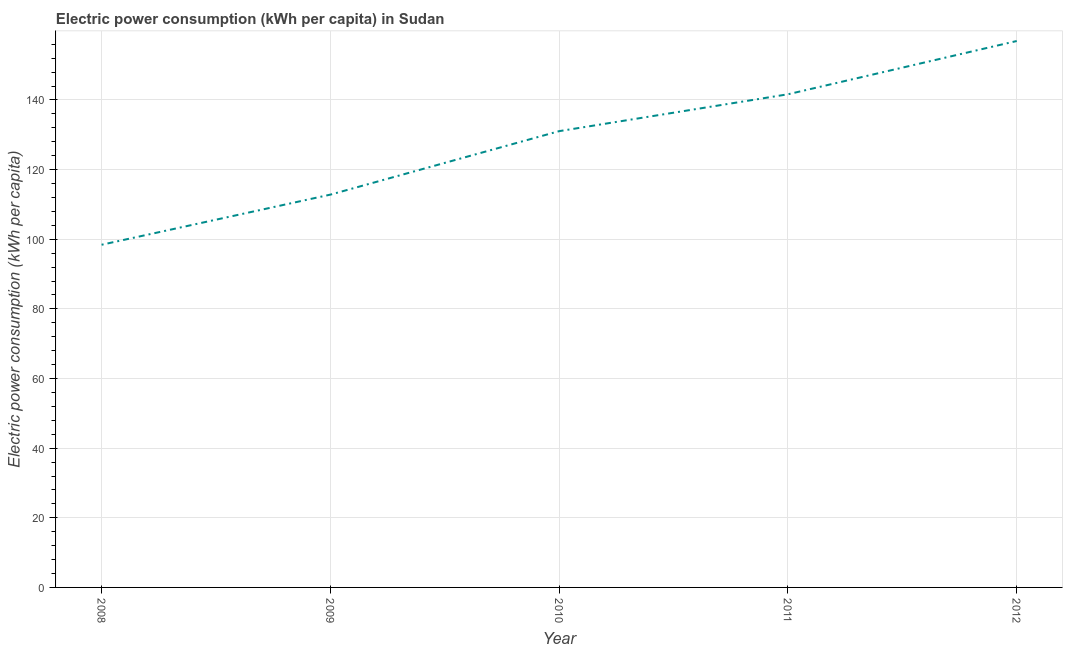What is the electric power consumption in 2009?
Make the answer very short. 112.82. Across all years, what is the maximum electric power consumption?
Provide a succinct answer. 156.94. Across all years, what is the minimum electric power consumption?
Keep it short and to the point. 98.42. In which year was the electric power consumption maximum?
Your answer should be compact. 2012. In which year was the electric power consumption minimum?
Give a very brief answer. 2008. What is the sum of the electric power consumption?
Give a very brief answer. 640.89. What is the difference between the electric power consumption in 2009 and 2012?
Offer a very short reply. -44.12. What is the average electric power consumption per year?
Ensure brevity in your answer.  128.18. What is the median electric power consumption?
Provide a short and direct response. 131.06. Do a majority of the years between 2009 and 2012 (inclusive) have electric power consumption greater than 92 kWh per capita?
Offer a terse response. Yes. What is the ratio of the electric power consumption in 2008 to that in 2012?
Offer a very short reply. 0.63. Is the electric power consumption in 2010 less than that in 2012?
Ensure brevity in your answer.  Yes. What is the difference between the highest and the second highest electric power consumption?
Offer a very short reply. 15.3. Is the sum of the electric power consumption in 2011 and 2012 greater than the maximum electric power consumption across all years?
Provide a succinct answer. Yes. What is the difference between the highest and the lowest electric power consumption?
Your response must be concise. 58.52. How many lines are there?
Ensure brevity in your answer.  1. How many years are there in the graph?
Make the answer very short. 5. Are the values on the major ticks of Y-axis written in scientific E-notation?
Provide a succinct answer. No. Does the graph contain any zero values?
Your answer should be very brief. No. Does the graph contain grids?
Make the answer very short. Yes. What is the title of the graph?
Ensure brevity in your answer.  Electric power consumption (kWh per capita) in Sudan. What is the label or title of the Y-axis?
Make the answer very short. Electric power consumption (kWh per capita). What is the Electric power consumption (kWh per capita) in 2008?
Give a very brief answer. 98.42. What is the Electric power consumption (kWh per capita) in 2009?
Provide a succinct answer. 112.82. What is the Electric power consumption (kWh per capita) of 2010?
Ensure brevity in your answer.  131.06. What is the Electric power consumption (kWh per capita) of 2011?
Keep it short and to the point. 141.65. What is the Electric power consumption (kWh per capita) in 2012?
Give a very brief answer. 156.94. What is the difference between the Electric power consumption (kWh per capita) in 2008 and 2009?
Your answer should be compact. -14.4. What is the difference between the Electric power consumption (kWh per capita) in 2008 and 2010?
Your answer should be very brief. -32.63. What is the difference between the Electric power consumption (kWh per capita) in 2008 and 2011?
Make the answer very short. -43.22. What is the difference between the Electric power consumption (kWh per capita) in 2008 and 2012?
Keep it short and to the point. -58.52. What is the difference between the Electric power consumption (kWh per capita) in 2009 and 2010?
Offer a very short reply. -18.23. What is the difference between the Electric power consumption (kWh per capita) in 2009 and 2011?
Provide a succinct answer. -28.82. What is the difference between the Electric power consumption (kWh per capita) in 2009 and 2012?
Ensure brevity in your answer.  -44.12. What is the difference between the Electric power consumption (kWh per capita) in 2010 and 2011?
Your answer should be very brief. -10.59. What is the difference between the Electric power consumption (kWh per capita) in 2010 and 2012?
Offer a terse response. -25.89. What is the difference between the Electric power consumption (kWh per capita) in 2011 and 2012?
Offer a very short reply. -15.3. What is the ratio of the Electric power consumption (kWh per capita) in 2008 to that in 2009?
Your answer should be compact. 0.87. What is the ratio of the Electric power consumption (kWh per capita) in 2008 to that in 2010?
Offer a very short reply. 0.75. What is the ratio of the Electric power consumption (kWh per capita) in 2008 to that in 2011?
Keep it short and to the point. 0.69. What is the ratio of the Electric power consumption (kWh per capita) in 2008 to that in 2012?
Provide a short and direct response. 0.63. What is the ratio of the Electric power consumption (kWh per capita) in 2009 to that in 2010?
Provide a succinct answer. 0.86. What is the ratio of the Electric power consumption (kWh per capita) in 2009 to that in 2011?
Give a very brief answer. 0.8. What is the ratio of the Electric power consumption (kWh per capita) in 2009 to that in 2012?
Your answer should be very brief. 0.72. What is the ratio of the Electric power consumption (kWh per capita) in 2010 to that in 2011?
Offer a very short reply. 0.93. What is the ratio of the Electric power consumption (kWh per capita) in 2010 to that in 2012?
Provide a short and direct response. 0.83. What is the ratio of the Electric power consumption (kWh per capita) in 2011 to that in 2012?
Provide a short and direct response. 0.9. 